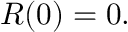Convert formula to latex. <formula><loc_0><loc_0><loc_500><loc_500>\ R ( 0 ) = 0 .</formula> 